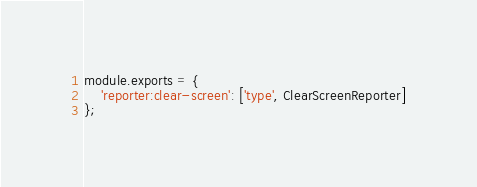<code> <loc_0><loc_0><loc_500><loc_500><_JavaScript_>module.exports = {
    'reporter:clear-screen': ['type', ClearScreenReporter]
};
</code> 